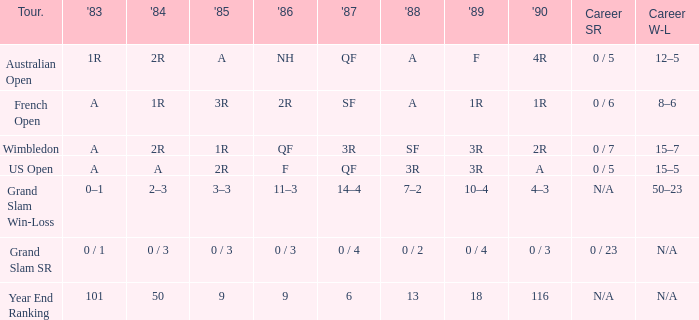Considering a 1986 nh and a 0/5 career sr, what were the corresponding results for 1985? A. 